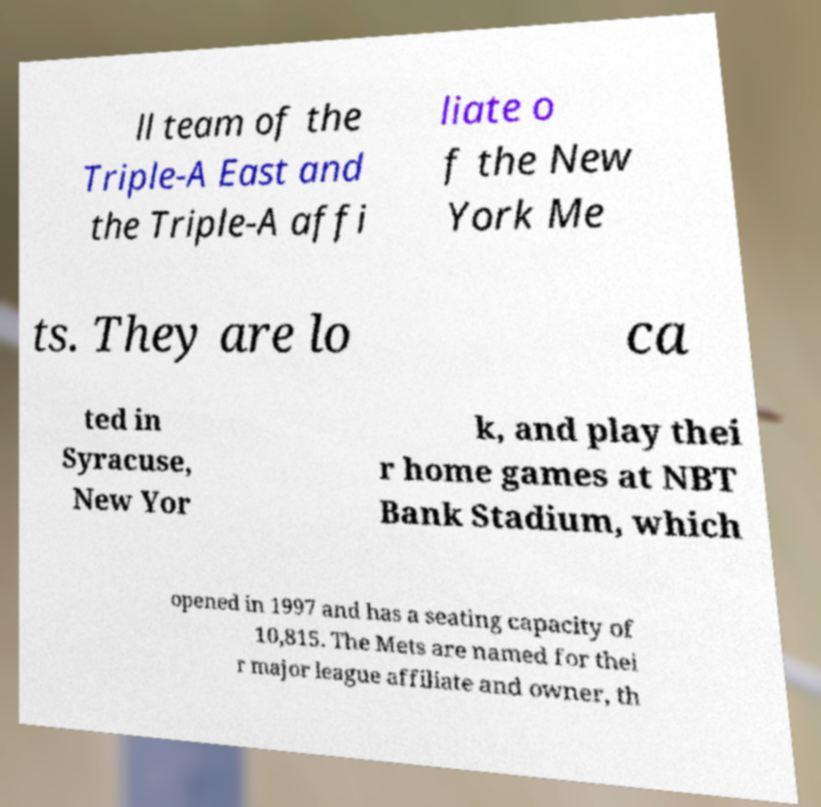Please identify and transcribe the text found in this image. ll team of the Triple-A East and the Triple-A affi liate o f the New York Me ts. They are lo ca ted in Syracuse, New Yor k, and play thei r home games at NBT Bank Stadium, which opened in 1997 and has a seating capacity of 10,815. The Mets are named for thei r major league affiliate and owner, th 